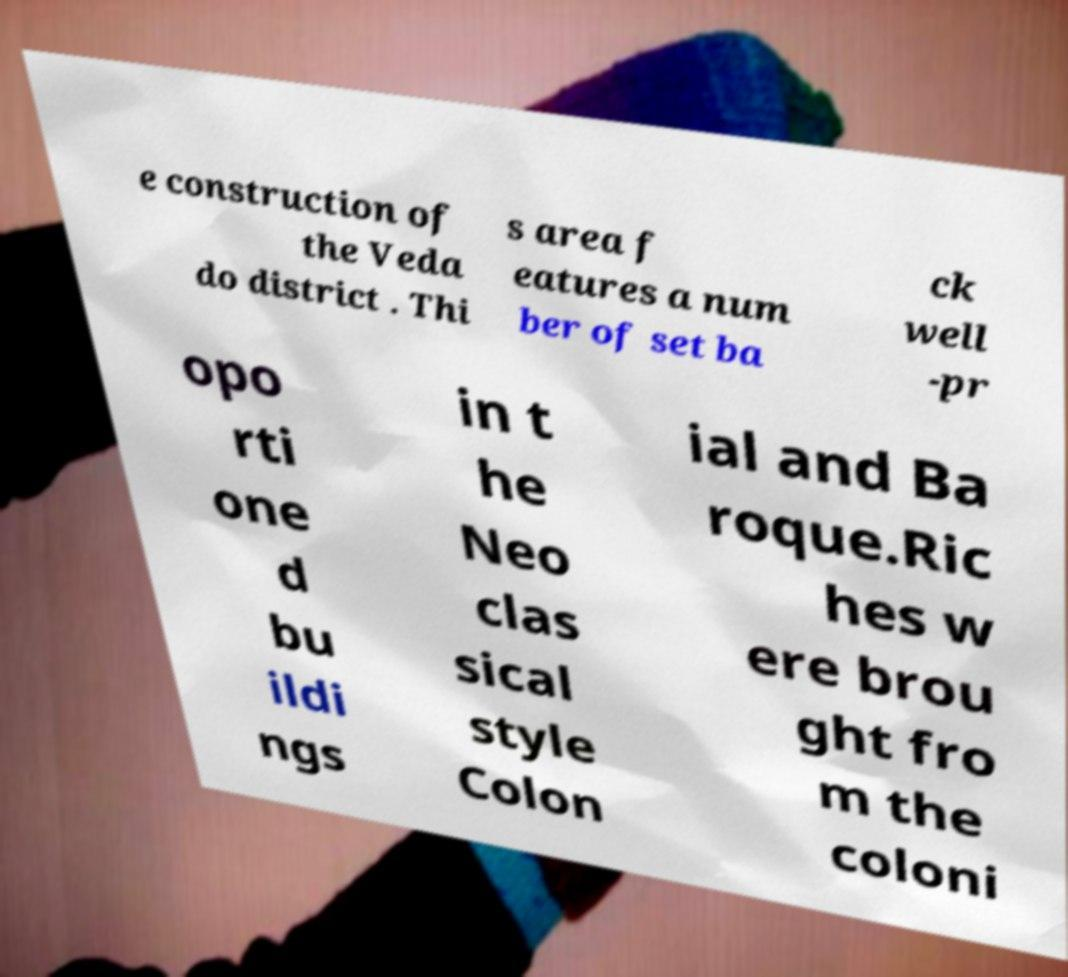There's text embedded in this image that I need extracted. Can you transcribe it verbatim? e construction of the Veda do district . Thi s area f eatures a num ber of set ba ck well -pr opo rti one d bu ildi ngs in t he Neo clas sical style Colon ial and Ba roque.Ric hes w ere brou ght fro m the coloni 